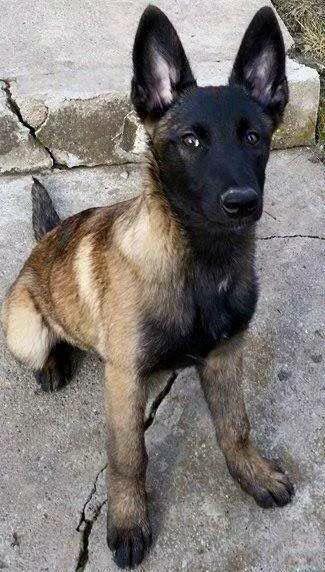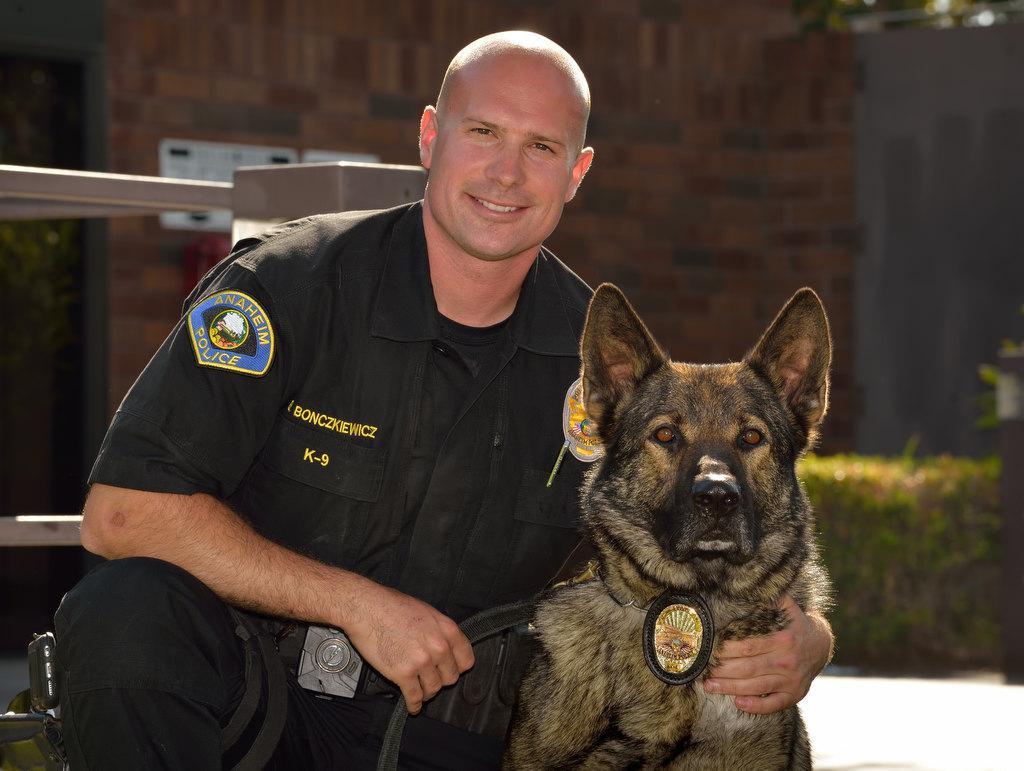The first image is the image on the left, the second image is the image on the right. Assess this claim about the two images: "No human is visible next to the german shepherd dog in the right image.". Correct or not? Answer yes or no. No. 